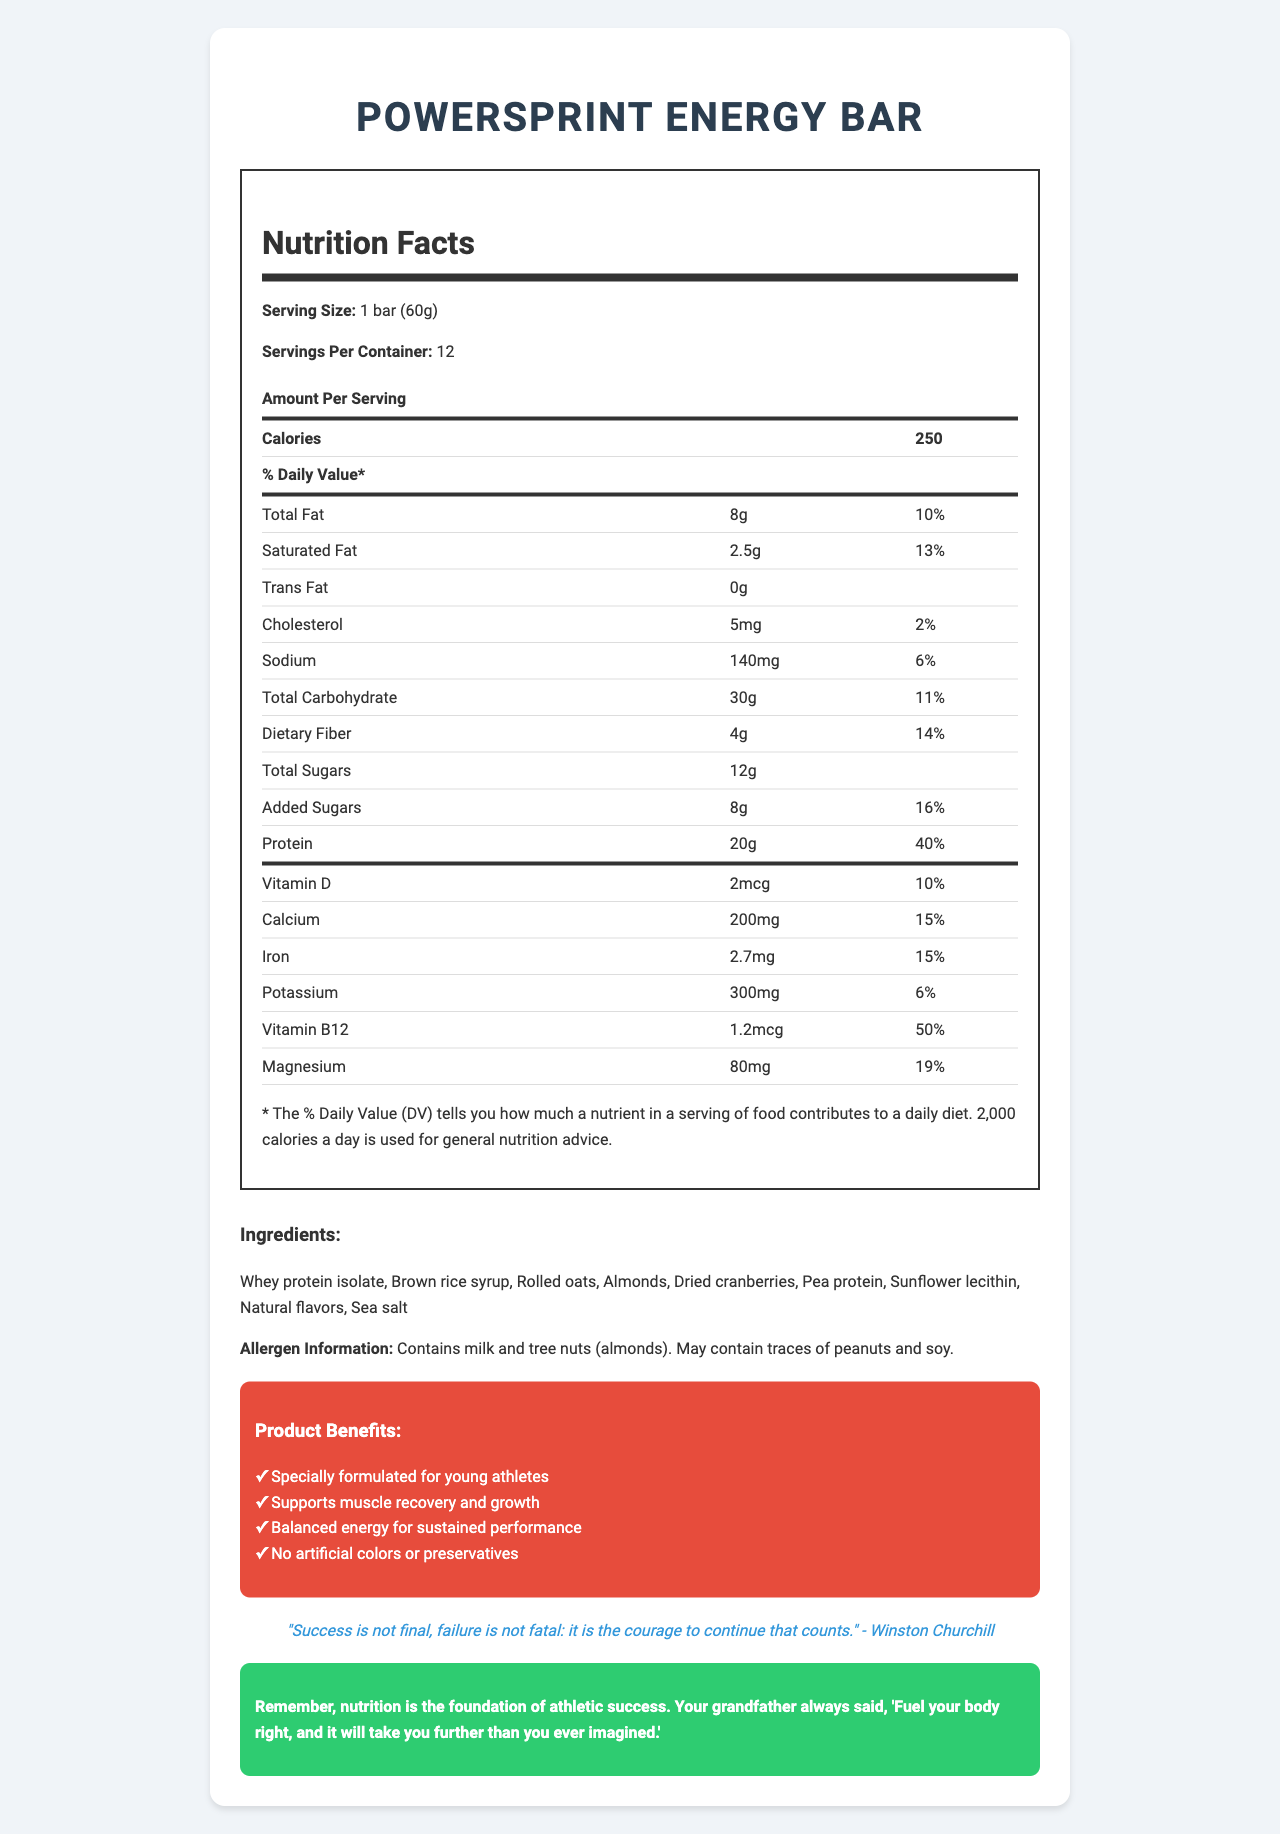what is the serving size for the PowerSprint Energy Bar? The serving size information is listed under the Nutrition Facts section and mentions that one serving size is 1 bar weighing 60 grams.
Answer: 1 bar (60g) how many calories are in one serving of the PowerSprint Energy Bar? The number of calories per serving is shown under the Nutrition Facts section under "Amount Per Serving".
Answer: 250 what is the total fat content per serving? The total fat content is listed as 8 grams in the Nutrition Facts section.
Answer: 8g how much protein does one bar of PowerSprint Energy Bar provide? The protein content is provided in the Nutrition Facts section, where it is listed as 20 grams.
Answer: 20g which vitamins are present in the PowerSprint Energy Bar? The vitamins present in the bar are listed in the Nutrition Facts section, which includes Vitamin D and Vitamin B12.
Answer: Vitamin D and Vitamin B12 how many servings are there in one container of PowerSprint Energy Bar? The number of servings per container is listed under the serving information section of the Nutrition Facts.
Answer: 12 how many grams of dietary fiber are in one serving? The amount of dietary fiber per serving can be found in the Nutrition Facts section, which lists it as 4 grams.
Answer: 4g what percentage of the daily value of calcium does one bar provide? The daily value percentage for calcium is listed in the Nutrition Facts section as 15%.
Answer: 15% which ingredient is used as the primary protein source in the PowerSprint Energy Bar? Under the ingredients section, the first listed ingredient is whey protein isolate, indicating its prominence.
Answer: Whey protein isolate what is the total amount of sugars per serving, including added sugars? The Nutrition Facts section lists total sugars as 12 grams, with 8 grams of that being added sugars.
Answer: 12g total sugars, 8g added sugars how do the marketing claims describe the bar's benefits for athletes? The marketing claims section outlines these benefits of the bar.
Answer: Specially formulated for young athletes, supports muscle recovery and growth, balanced energy for sustained performance, no artificial colors or preservatives what is the calorie contribution from protein in one serving, assuming 4 calories per gram of protein? With 20 grams of protein and 4 calories per gram, the protein contributes 20 * 4 = 80 calories.
Answer: 80 calories does the PowerSprint Energy Bar contain artificial preservatives? One of the marketing claims explicitly states that the bar contains no artificial colors or preservatives.
Answer: No which of the following allergens are contained in the PowerSprint Energy Bar? A. Peanuts B. Soy C. Almonds D. Eggs The allergen information states that the bar contains milk and tree nuts (almonds).
Answer: C. Almonds what is the motivational quote included in the document? A. "Success is not final, failure is not fatal: it is the courage to continue that counts." - Winston Churchill B. "The only limit to our realization of tomorrow is our doubts of today." - Franklin D. Roosevelt C. "You miss 100% of the shots you don’t take." - Wayne Gretzky The quote is listed towards the end of the document.
Answer: A. "Success is not final, failure is not fatal: it is the courage to continue that counts." - Winston Churchill does the PowerSprint Energy Bar contain trans fat? The Nutrition Facts section explicitly states that the trans fat content is 0 grams.
Answer: No provide a brief summary of the PowerSprint Energy Bar document. The summary captures the main sections and points of the document, highlighting its purpose and content.
Answer: The document provides detailed nutrition information for the PowerSprint Energy Bar, which is designed for young athletes. It outlines the serving size, number of servings per container, and the nutritional contents including calories, fats, protein, and vitamins. The document also lists ingredients, allergen information, and marketing claims that highlight the benefits of the bar for athletes. A motivational quote and a piece of wisdom from the athlete's grandfather emphasize the importance of proper nutrition. what is the shelf life of the PowerSprint Energy Bar? The document does not provide any information regarding the shelf life of the PowerSprint Energy Bar.
Answer: Not enough information 